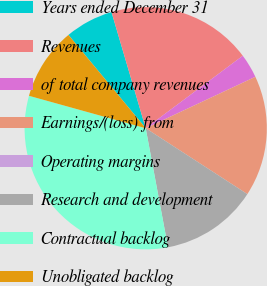Convert chart. <chart><loc_0><loc_0><loc_500><loc_500><pie_chart><fcel>Years ended December 31<fcel>Revenues<fcel>of total company revenues<fcel>Earnings/(loss) from<fcel>Operating margins<fcel>Research and development<fcel>Contractual backlog<fcel>Unobligated backlog<nl><fcel>6.45%<fcel>19.35%<fcel>3.23%<fcel>16.13%<fcel>0.0%<fcel>12.9%<fcel>32.26%<fcel>9.68%<nl></chart> 